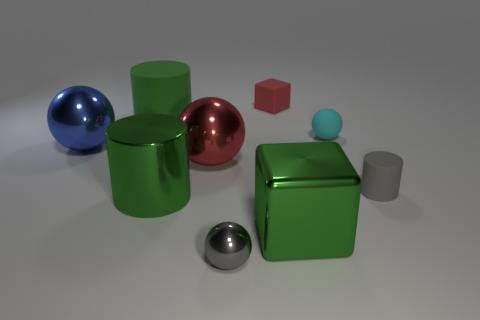There is a cube that is right of the small matte thing behind the large matte cylinder; is there a tiny gray rubber cylinder that is in front of it?
Ensure brevity in your answer.  No. Is there any other thing that has the same shape as the small gray matte object?
Ensure brevity in your answer.  Yes. Is there a large shiny object?
Your response must be concise. Yes. Is the tiny ball left of the matte block made of the same material as the ball on the right side of the gray metallic sphere?
Make the answer very short. No. There is a rubber thing that is in front of the large metallic ball behind the large shiny sphere on the right side of the big metallic cylinder; how big is it?
Your answer should be compact. Small. How many small red objects are made of the same material as the large cube?
Offer a terse response. 0. Is the number of big brown matte balls less than the number of spheres?
Provide a succinct answer. Yes. The cyan object that is the same shape as the large blue metal object is what size?
Offer a terse response. Small. Is the material of the large thing that is behind the blue shiny sphere the same as the tiny cylinder?
Provide a short and direct response. Yes. Do the small gray rubber thing and the big red object have the same shape?
Keep it short and to the point. No. 